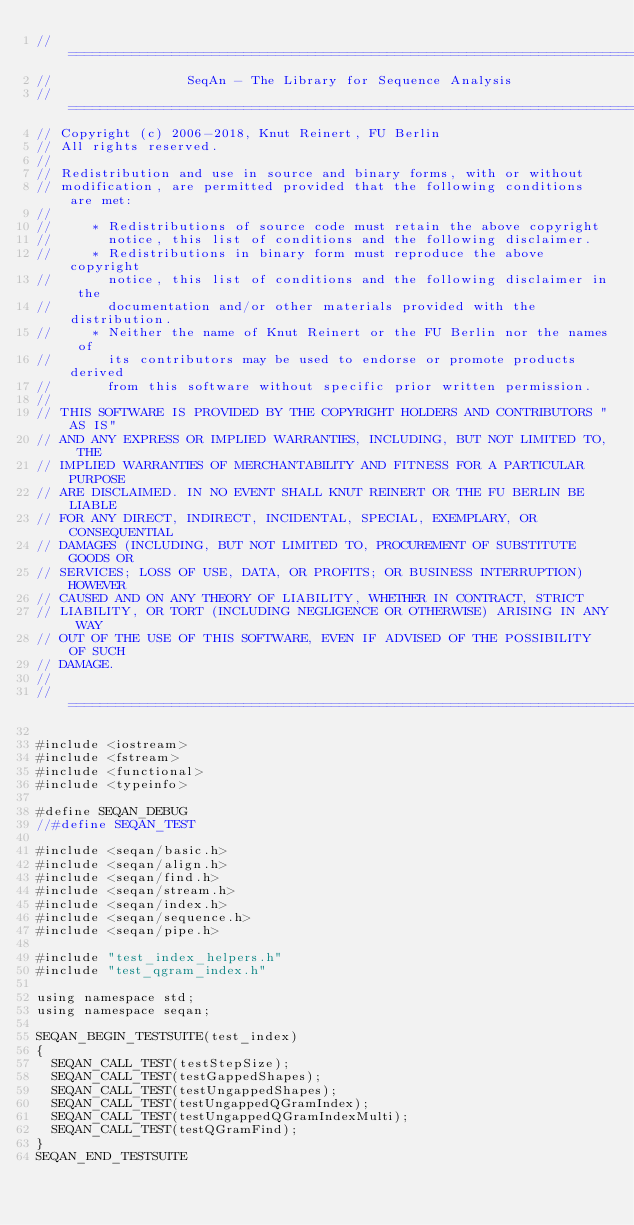<code> <loc_0><loc_0><loc_500><loc_500><_C++_>// ==========================================================================
//                 SeqAn - The Library for Sequence Analysis
// ==========================================================================
// Copyright (c) 2006-2018, Knut Reinert, FU Berlin
// All rights reserved.
//
// Redistribution and use in source and binary forms, with or without
// modification, are permitted provided that the following conditions are met:
//
//     * Redistributions of source code must retain the above copyright
//       notice, this list of conditions and the following disclaimer.
//     * Redistributions in binary form must reproduce the above copyright
//       notice, this list of conditions and the following disclaimer in the
//       documentation and/or other materials provided with the distribution.
//     * Neither the name of Knut Reinert or the FU Berlin nor the names of
//       its contributors may be used to endorse or promote products derived
//       from this software without specific prior written permission.
//
// THIS SOFTWARE IS PROVIDED BY THE COPYRIGHT HOLDERS AND CONTRIBUTORS "AS IS"
// AND ANY EXPRESS OR IMPLIED WARRANTIES, INCLUDING, BUT NOT LIMITED TO, THE
// IMPLIED WARRANTIES OF MERCHANTABILITY AND FITNESS FOR A PARTICULAR PURPOSE
// ARE DISCLAIMED. IN NO EVENT SHALL KNUT REINERT OR THE FU BERLIN BE LIABLE
// FOR ANY DIRECT, INDIRECT, INCIDENTAL, SPECIAL, EXEMPLARY, OR CONSEQUENTIAL
// DAMAGES (INCLUDING, BUT NOT LIMITED TO, PROCUREMENT OF SUBSTITUTE GOODS OR
// SERVICES; LOSS OF USE, DATA, OR PROFITS; OR BUSINESS INTERRUPTION) HOWEVER
// CAUSED AND ON ANY THEORY OF LIABILITY, WHETHER IN CONTRACT, STRICT
// LIABILITY, OR TORT (INCLUDING NEGLIGENCE OR OTHERWISE) ARISING IN ANY WAY
// OUT OF THE USE OF THIS SOFTWARE, EVEN IF ADVISED OF THE POSSIBILITY OF SUCH
// DAMAGE.
//
// ==========================================================================

#include <iostream>
#include <fstream>
#include <functional>
#include <typeinfo>

#define SEQAN_DEBUG
//#define SEQAN_TEST

#include <seqan/basic.h>
#include <seqan/align.h>
#include <seqan/find.h>
#include <seqan/stream.h>
#include <seqan/index.h>
#include <seqan/sequence.h>
#include <seqan/pipe.h>

#include "test_index_helpers.h"
#include "test_qgram_index.h"

using namespace std;
using namespace seqan;

SEQAN_BEGIN_TESTSUITE(test_index)
{
	SEQAN_CALL_TEST(testStepSize);
	SEQAN_CALL_TEST(testGappedShapes);
	SEQAN_CALL_TEST(testUngappedShapes);
	SEQAN_CALL_TEST(testUngappedQGramIndex);
	SEQAN_CALL_TEST(testUngappedQGramIndexMulti);
	SEQAN_CALL_TEST(testQGramFind);
}
SEQAN_END_TESTSUITE
</code> 